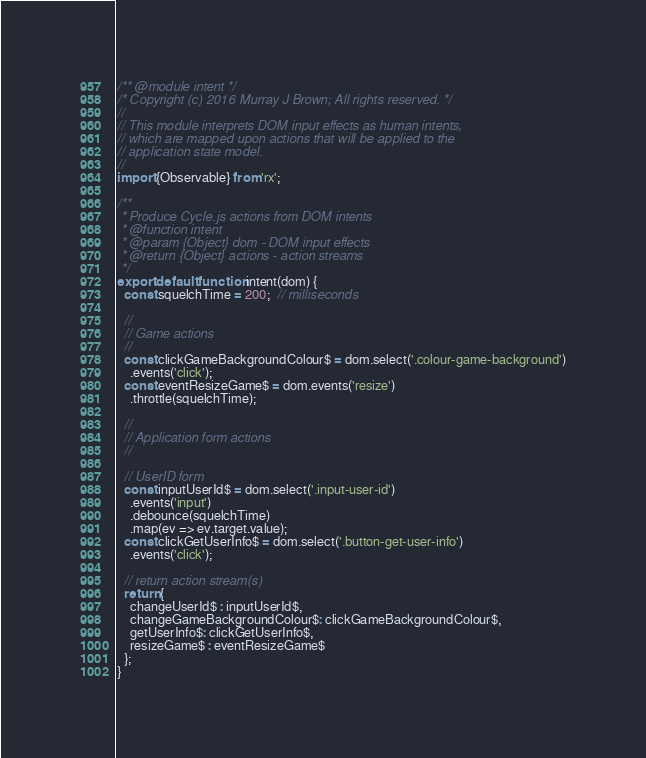Convert code to text. <code><loc_0><loc_0><loc_500><loc_500><_JavaScript_>/** @module intent */
/* Copyright (c) 2016 Murray J Brown; All rights reserved. */
//
// This module interprets DOM input effects as human intents,
// which are mapped upon actions that will be applied to the
// application state model.
//
import {Observable} from 'rx';

/**
 * Produce Cycle.js actions from DOM intents
 * @function intent
 * @param {Object} dom - DOM input effects
 * @return {Object} actions - action streams
 */
export default function intent(dom) {
  const squelchTime = 200;  // milliseconds

  //
  // Game actions
  //
  const clickGameBackgroundColour$ = dom.select('.colour-game-background')
    .events('click');
  const eventResizeGame$ = dom.events('resize')
    .throttle(squelchTime);

  //
  // Application form actions
  //

  // UserID form
  const inputUserId$ = dom.select('.input-user-id')
    .events('input')
    .debounce(squelchTime)
    .map(ev => ev.target.value);
  const clickGetUserInfo$ = dom.select('.button-get-user-info')
    .events('click');

  // return action stream(s)
  return {
    changeUserId$ : inputUserId$,
    changeGameBackgroundColour$: clickGameBackgroundColour$,
    getUserInfo$: clickGetUserInfo$,
    resizeGame$ : eventResizeGame$
  };
}
</code> 